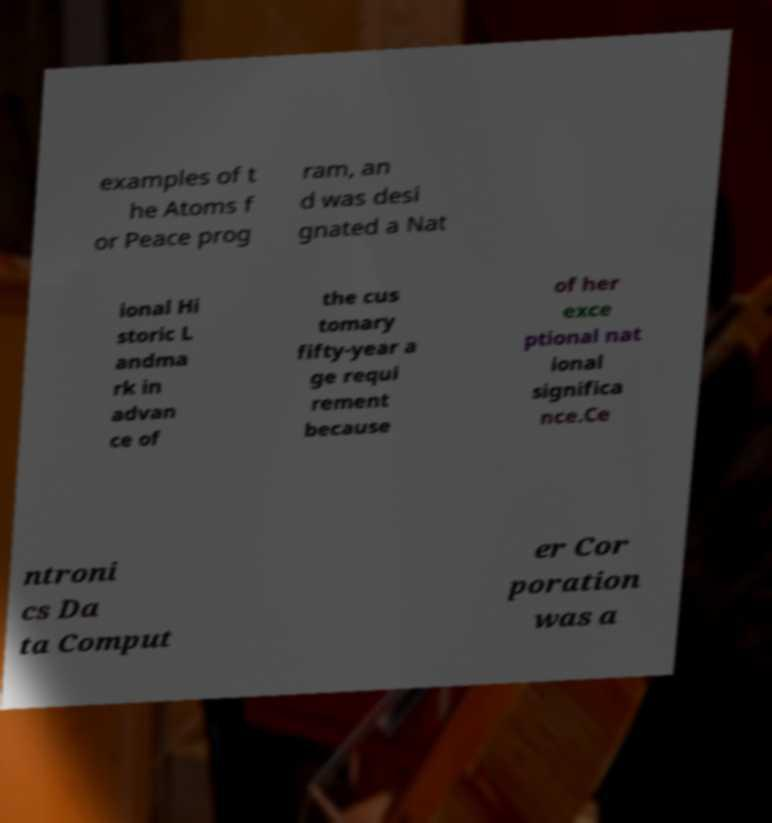Could you extract and type out the text from this image? examples of t he Atoms f or Peace prog ram, an d was desi gnated a Nat ional Hi storic L andma rk in advan ce of the cus tomary fifty-year a ge requi rement because of her exce ptional nat ional significa nce.Ce ntroni cs Da ta Comput er Cor poration was a 